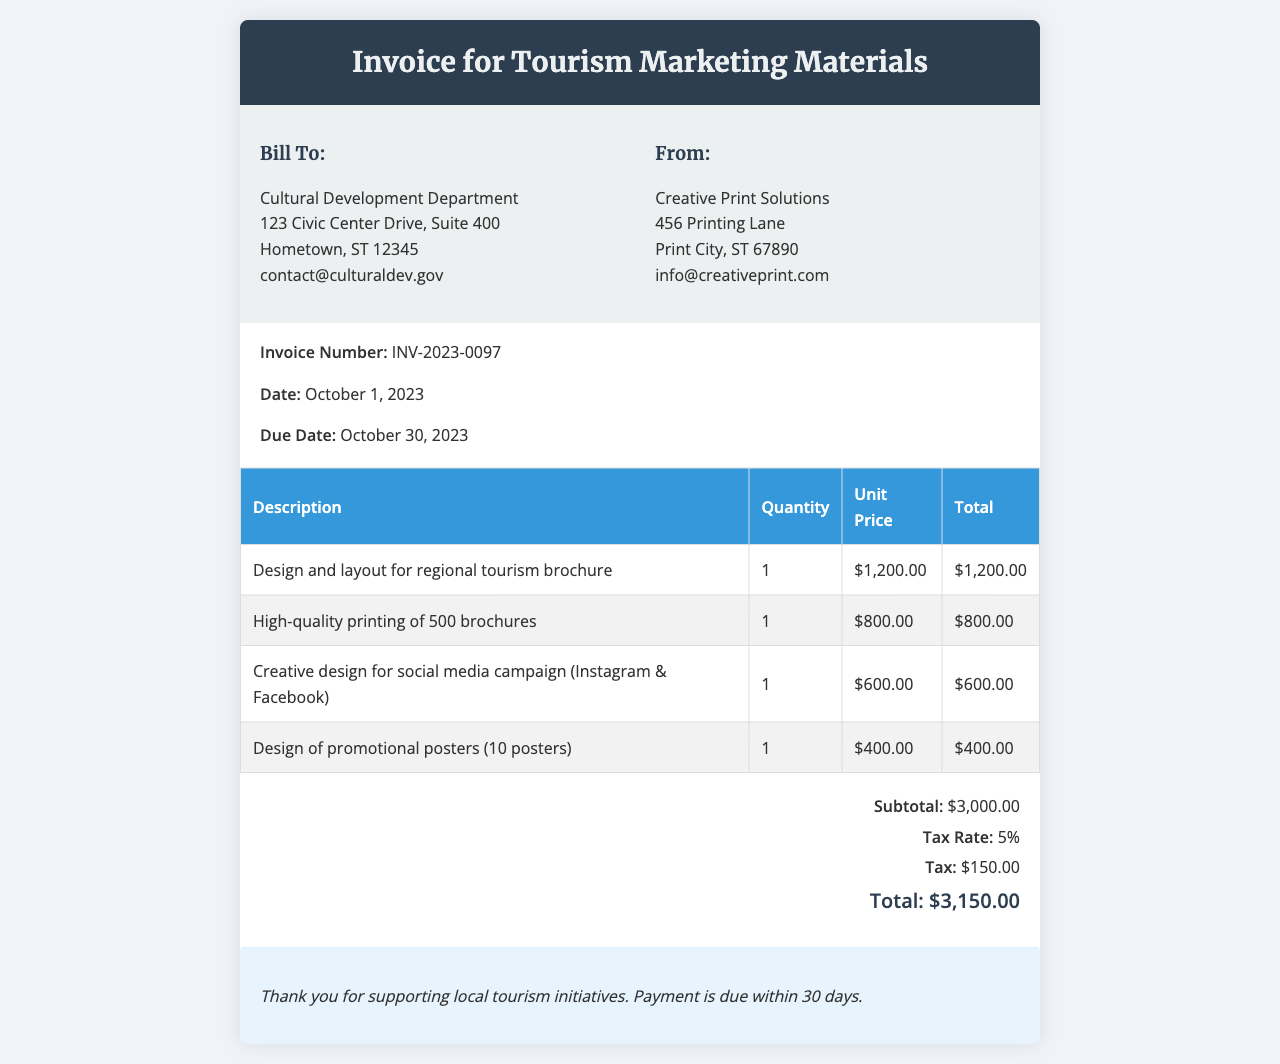What is the invoice number? The invoice number is provided in the document as a unique identifier, which is INV-2023-0097.
Answer: INV-2023-0097 Who is the billing recipient? The billing recipient is shown in the "Bill To" section, which lists the Cultural Development Department.
Answer: Cultural Development Department What is the due date of the invoice? The document specifies a due date, which is important for payment timelines, and it is October 30, 2023.
Answer: October 30, 2023 What is the subtotal of the invoice? The subtotal is calculated before tax is added, which is clearly stated as $3,000.00.
Answer: $3,000.00 How many brochures were printed? The number of brochures printed is included in the line item for printing services, which indicates that 500 brochures were printed.
Answer: 500 What is the tax amount? The tax amount is calculated based on the subtotal and tax rate, which is explicitly mentioned as $150.00.
Answer: $150.00 What is the total cost of the invoice? The total cost is the sum of the subtotal and tax amount, clearly stated in the document as $3,150.00.
Answer: $3,150.00 Which company provided the services? The provider is listed in the "From" section of the document, which shows Creative Print Solutions.
Answer: Creative Print Solutions How many promotional posters were designed? The document mentions that 10 posters were designed under one of the line items related to promotional materials.
Answer: 10 